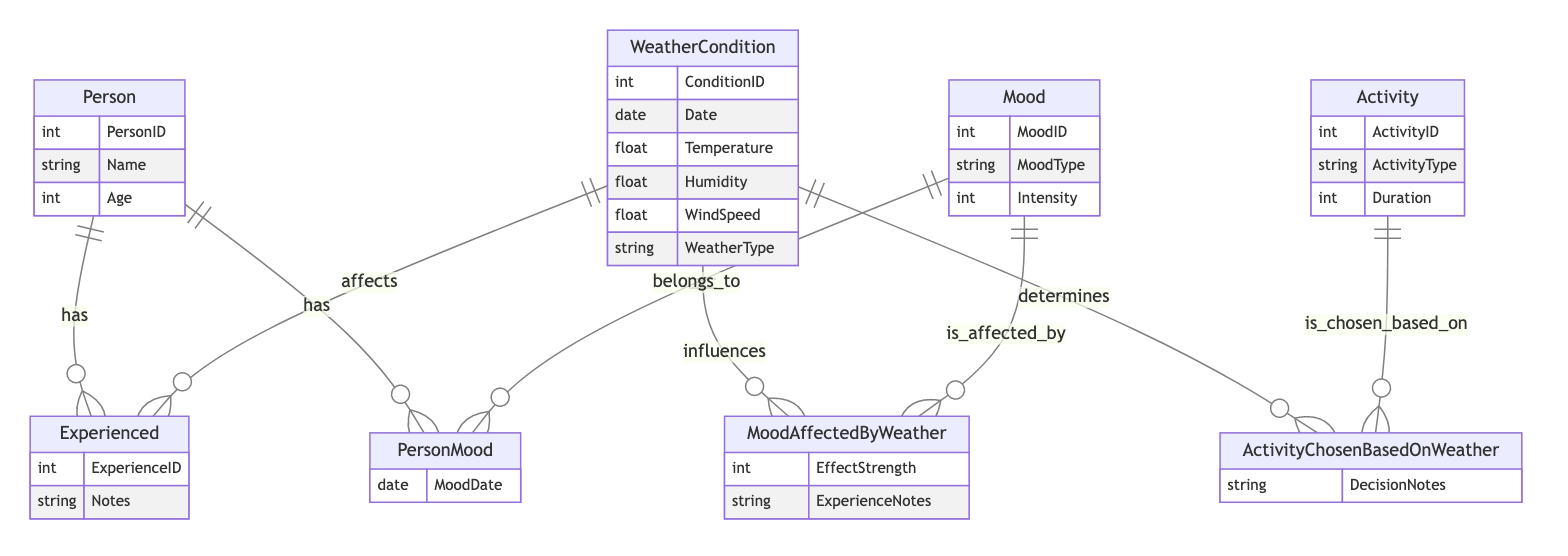What is the name of the relationship between Person and WeatherCondition? The relationship between Person and WeatherCondition is called "Experienced." This is visible in the relationships section of the diagram where it indicates how persons experience different weather conditions.
Answer: Experienced How many attributes does the Mood entity have? The Mood entity has three attributes: MoodID, MoodType, and Intensity. This can be confirmed by counting the listed attributes under the Mood entity in the diagram.
Answer: 3 What type of information is stored in the ActivityChosenBasedOnWeather relationship? The ActivityChosenBasedOnWeather relationship stores decision notes. This is evident from the attributes listed under this relationship label in the diagram.
Answer: DecisionNotes Which entity has the attribute "MoodDate"? The attribute "MoodDate" belongs to the PersonMood entity. The diagram clearly shows this attribute under the PersonMood entity section.
Answer: PersonMood What is the maximum number of WeatherCondition entities that can be linked to a single Person? A single Person can experience multiple WeatherCondition entities, as indicated by the "o{" notation representing a one-to-many relationship in the diagram. There is no defined upper limit visually in the diagram.
Answer: Many How is Mood influenced by WeatherCondition? Mood is influenced by WeatherCondition through the MoodAffectedByWeather relationship, which explicitly connects the two entities. This is shown in the relationships section in the diagram.
Answer: MoodAffectedByWeather What attribute differentiates the Activity entity from Mood? The Activity entity includes the attribute Duration, which is not present in the Mood entity. This distinction can be verified by comparing the attributes listed under each entity in the diagram.
Answer: Duration What does the EffectStrength attribute in the MoodAffectedByWeather relationship signify? The EffectStrength attribute signifies the measure of how strongly the weather affects mood, as inferred by its naming and placement in the MoodAffectedByWeather relationship.
Answer: Strength of effect How many entities does the PersonMood relationship connect? The PersonMood relationship connects two entities: Person and Mood. This can be confirmed by examining the relationship descriptions in the diagram.
Answer: 2 What type of weather information is recorded in the WeatherCondition entity? The WeatherCondition entity records information like Temperature, Humidity, WindSpeed, and WeatherType. These specific attributes are listed under the WeatherCondition entity in the diagram.
Answer: Temperature, Humidity, WindSpeed, WeatherType 